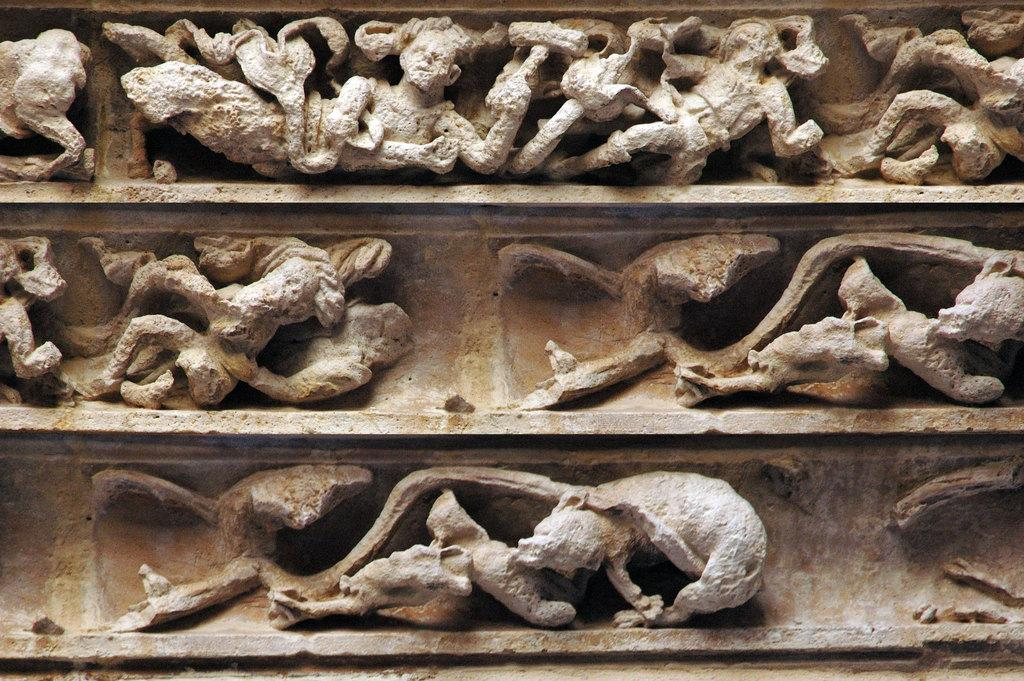What type of material is used to create the sculptures in the image? The sculptures in the image are made up of rock. What do the sculptures resemble in the image? The sculptures resemble an ancient wall. What type of flower can be seen growing near the sculptures in the image? There are no flowers present in the image; it features rock sculptures resembling an ancient wall. How many men are visible interacting with the sculptures in the image? There are no men present in the image; it features rock sculptures resembling an ancient wall. 